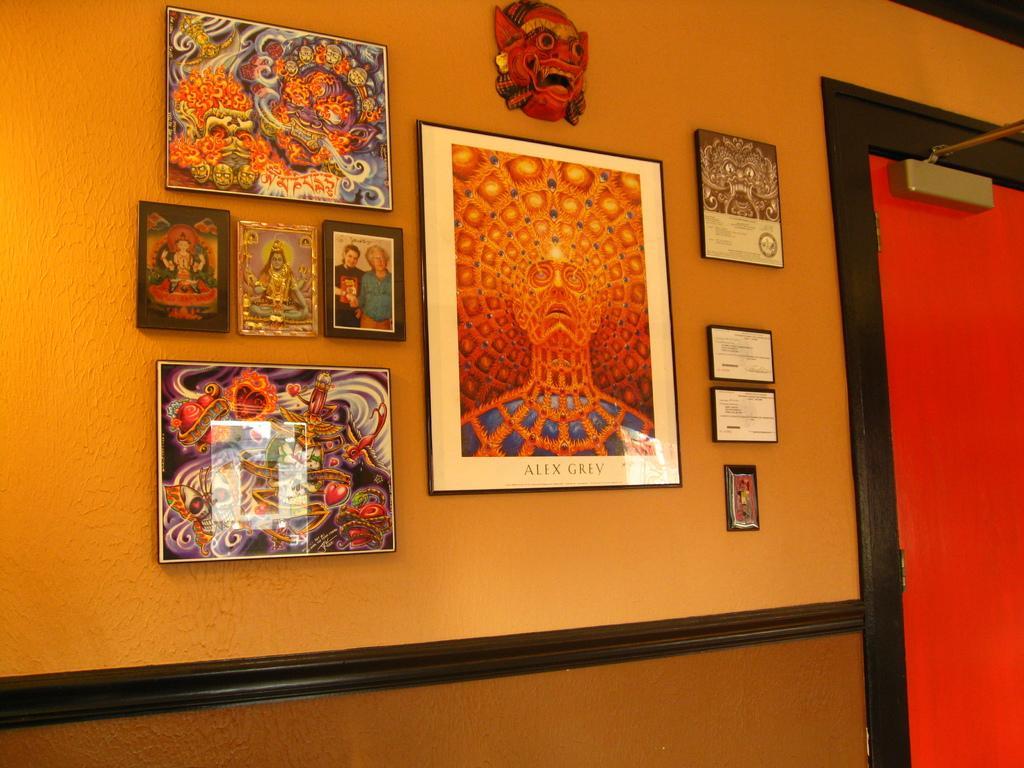Can you describe this image briefly? This image is taken indoors. In this image there is a wall with a few picture frames on it and there is a face mask on the wall. On the right side of the image there is a door. The door is red in color. 